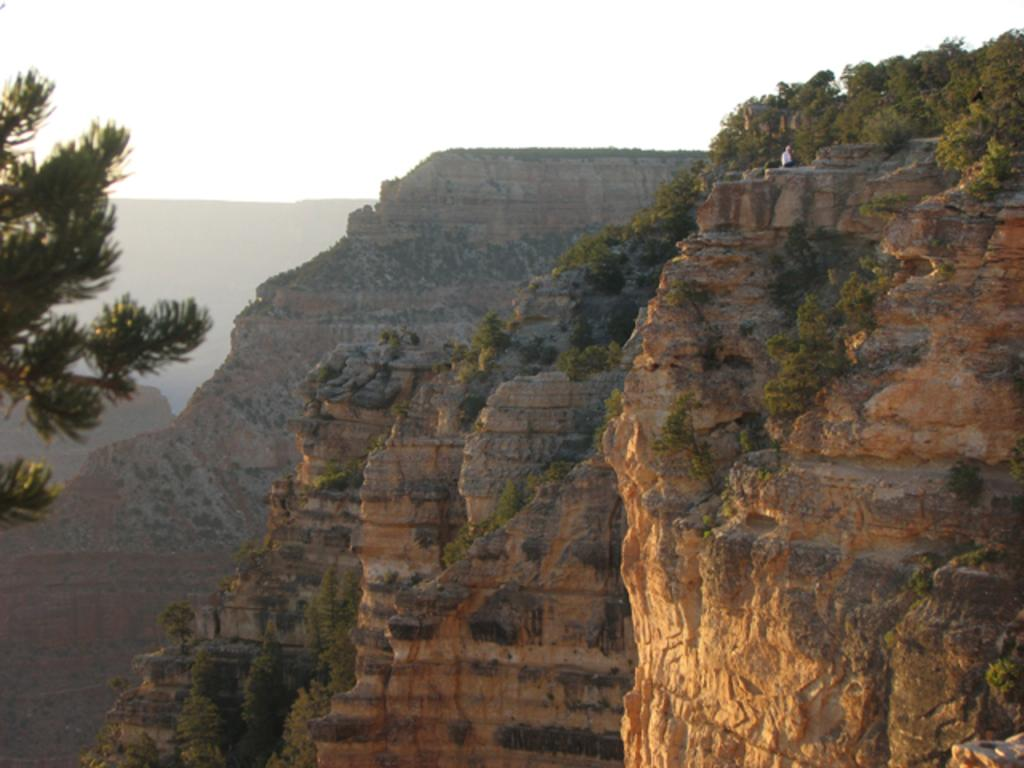What type of natural landform can be seen in the image? There are mountains in the image. What type of vegetation is present in the image? There are trees in the image. What can be seen in the sky in the image? There are clouds visible in the sky. What type of thread is being used to sew the coat in the image? There is no coat or thread present in the image; it features mountains, trees, and clouds. 